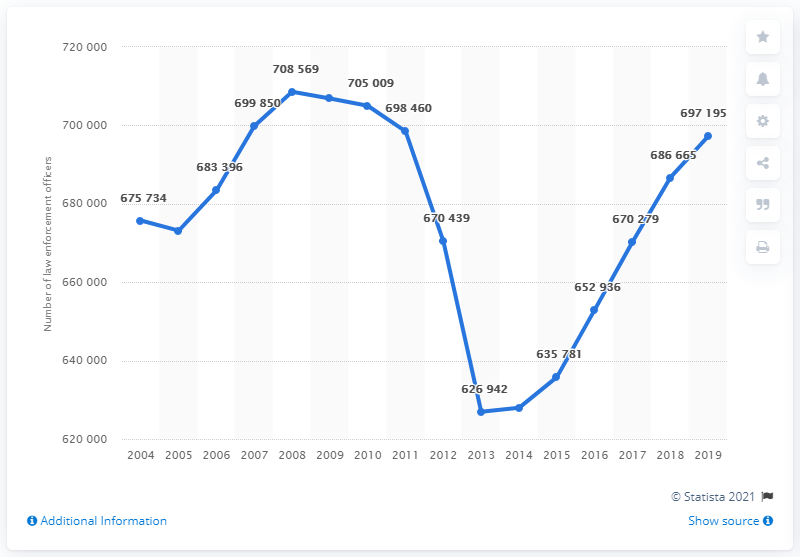Point out several critical features in this image. In 2013, there were the fewest number of law enforcement officers. The difference between 2008 and 2019 in the numbers is 11,374. 